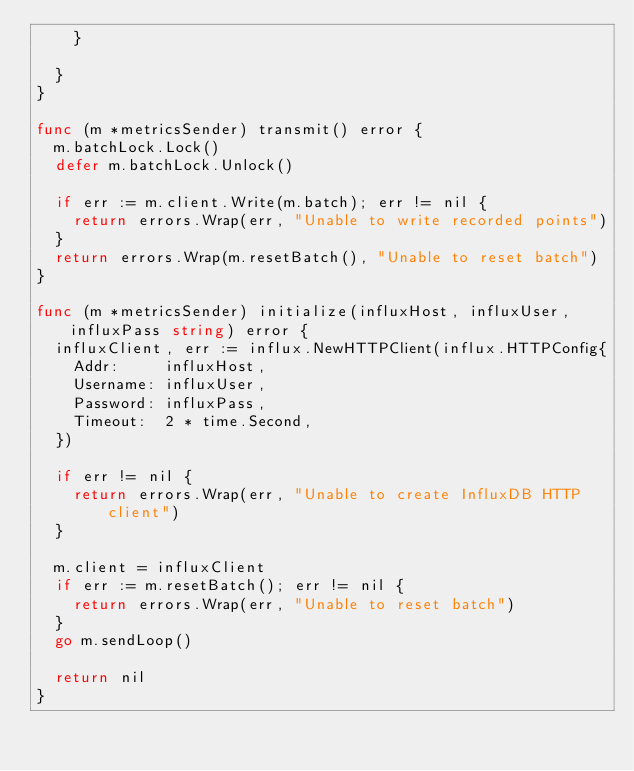Convert code to text. <code><loc_0><loc_0><loc_500><loc_500><_Go_>		}

	}
}

func (m *metricsSender) transmit() error {
	m.batchLock.Lock()
	defer m.batchLock.Unlock()

	if err := m.client.Write(m.batch); err != nil {
		return errors.Wrap(err, "Unable to write recorded points")
	}
	return errors.Wrap(m.resetBatch(), "Unable to reset batch")
}

func (m *metricsSender) initialize(influxHost, influxUser, influxPass string) error {
	influxClient, err := influx.NewHTTPClient(influx.HTTPConfig{
		Addr:     influxHost,
		Username: influxUser,
		Password: influxPass,
		Timeout:  2 * time.Second,
	})

	if err != nil {
		return errors.Wrap(err, "Unable to create InfluxDB HTTP client")
	}

	m.client = influxClient
	if err := m.resetBatch(); err != nil {
		return errors.Wrap(err, "Unable to reset batch")
	}
	go m.sendLoop()

	return nil
}
</code> 